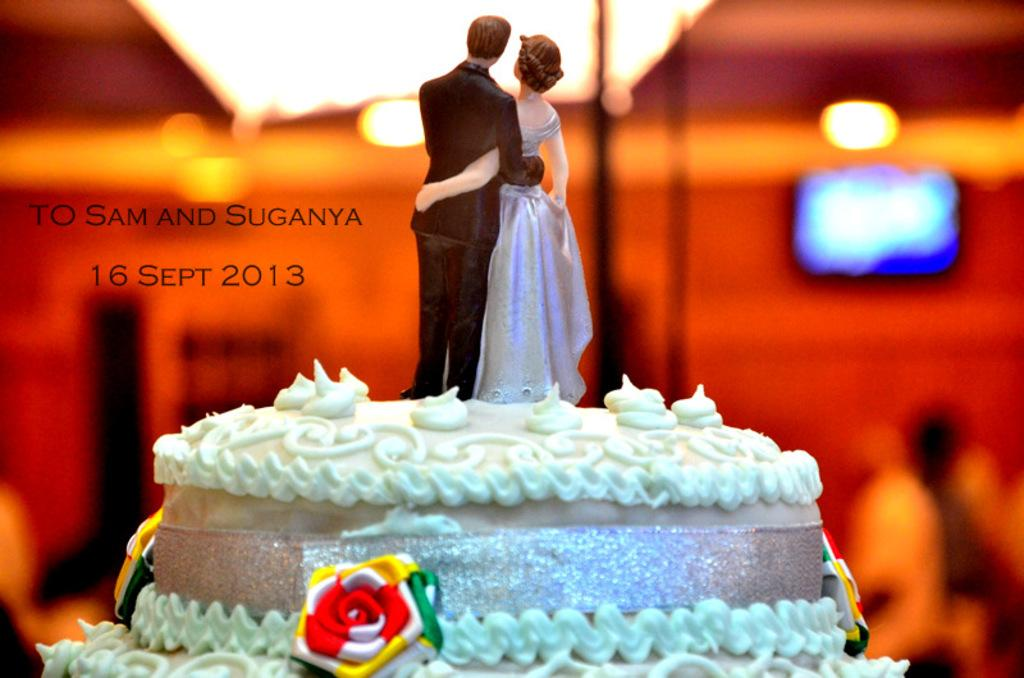What is on top of the cake in the image? There are two dolls on the cake. Can you describe the background of the image? The background behind the cake is blurred. Is there any additional information about the image itself? Yes, there is a watermark on the image. What type of wrench is being used to decorate the cake in the image? There is no wrench present in the image; the decorations on the cake consist of two dolls. 